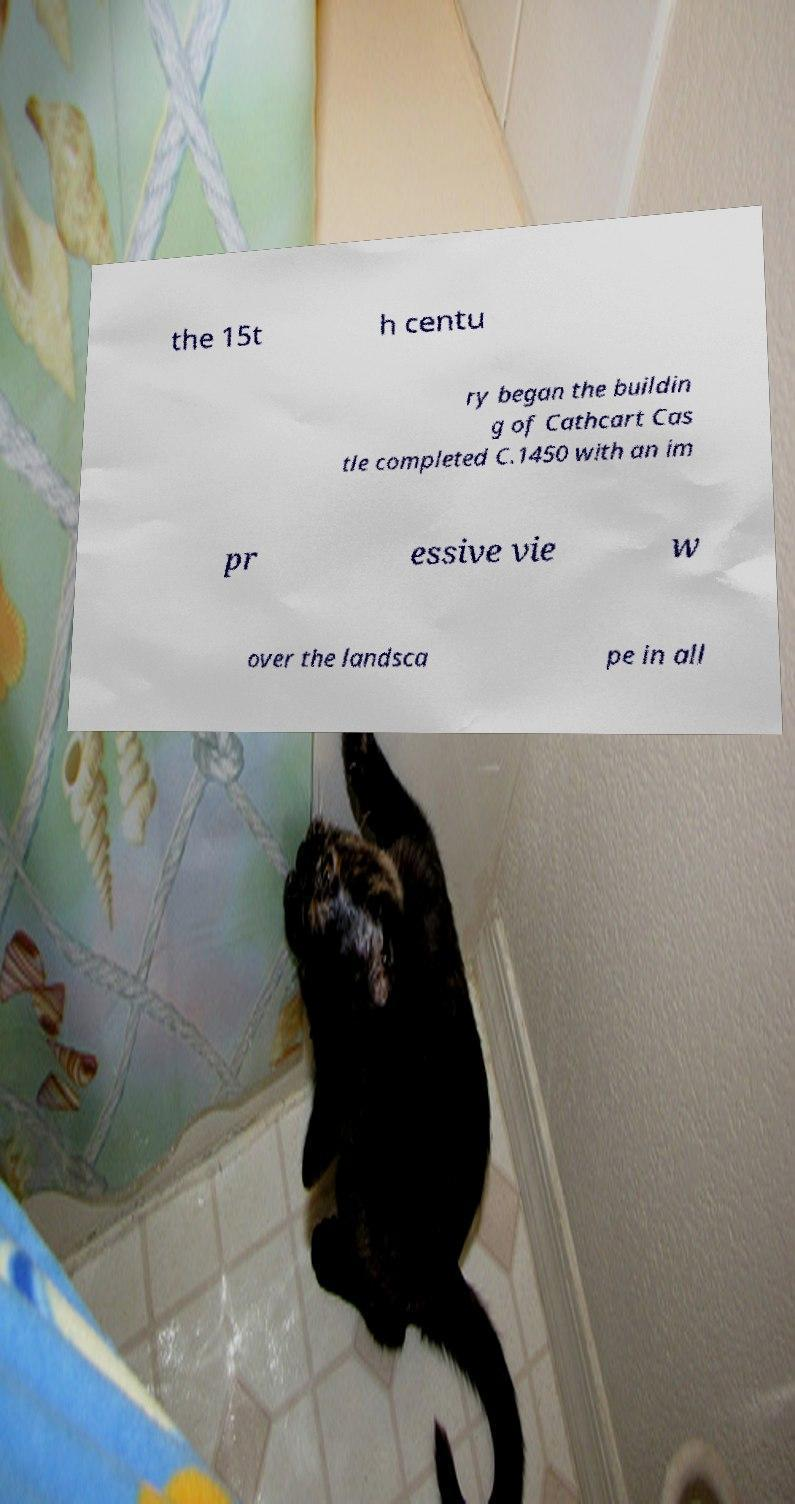Could you extract and type out the text from this image? the 15t h centu ry began the buildin g of Cathcart Cas tle completed C.1450 with an im pr essive vie w over the landsca pe in all 